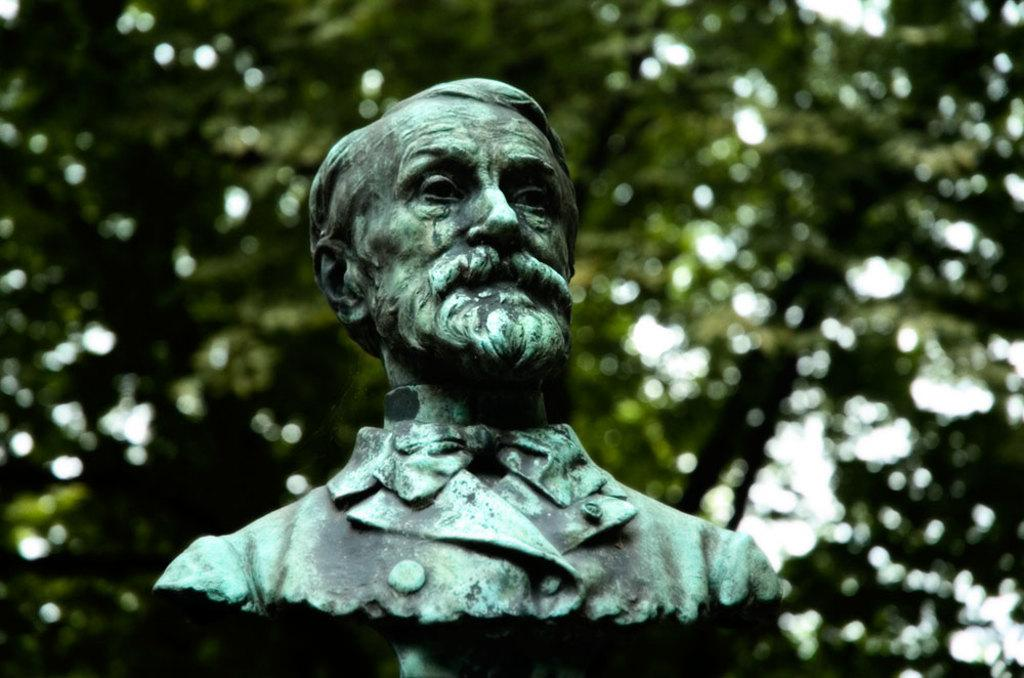What is the main subject of the image? There is a statue of a man in the image. What can be seen in the background of the image? There are trees in the background of the image. What type of force is being exerted by the ghost in the image? There is no ghost present in the image, so it is not possible to determine what type of force might be exerted. 